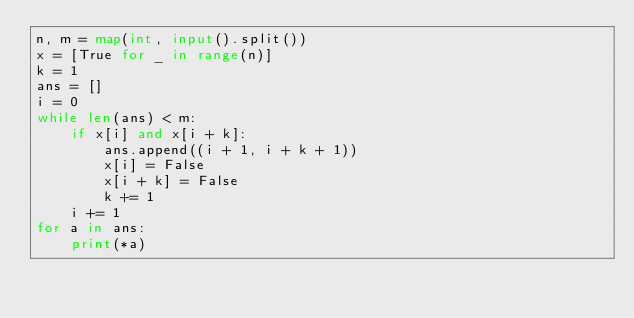<code> <loc_0><loc_0><loc_500><loc_500><_Python_>n, m = map(int, input().split())
x = [True for _ in range(n)]
k = 1
ans = []
i = 0
while len(ans) < m:
    if x[i] and x[i + k]:
        ans.append((i + 1, i + k + 1))
        x[i] = False
        x[i + k] = False
        k += 1
    i += 1
for a in ans:
    print(*a)
</code> 